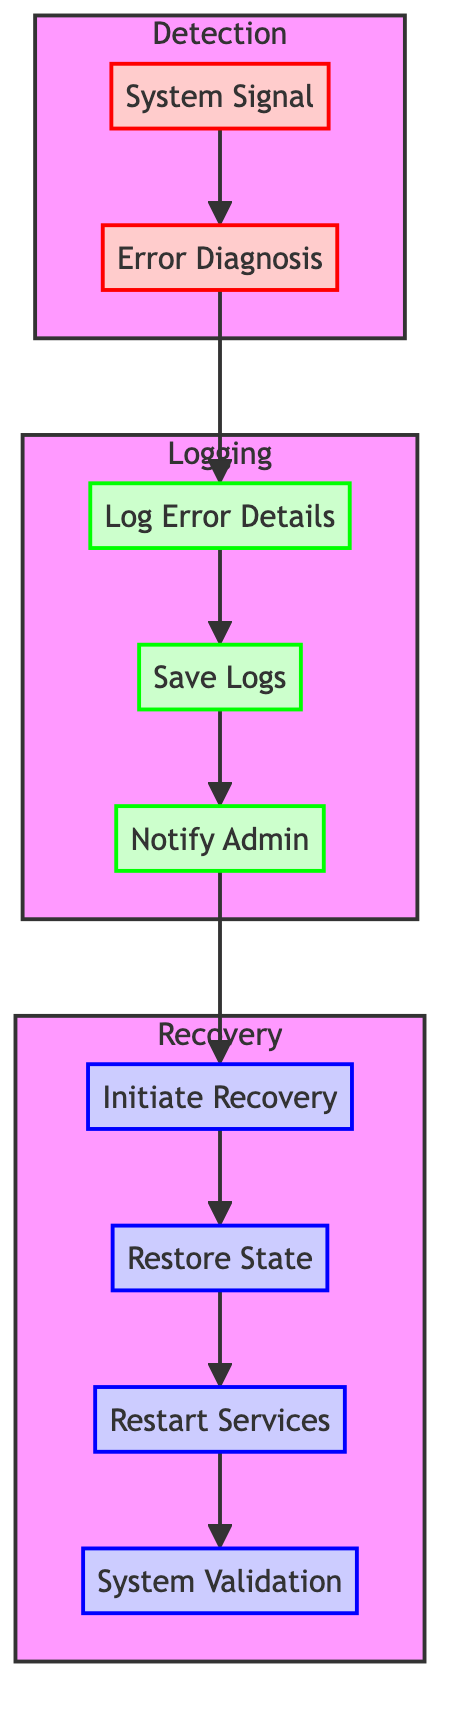What is the first step in the detection phase? The first step in the detection phase is indicated by the node labeled "System Signal," which shows where the detection process begins.
Answer: System Signal How many steps are in the logging phase? The logging phase consists of three steps: "Log Error Details," "Save Logs," and "Notify Admin," as identified by the respective nodes connected in the diagram.
Answer: 3 Which step comes after "Restore State"? Following "Restore State," the next step is "Restart Services," illustrated by the flow indicating the sequence of operations in the recovery phase.
Answer: Restart Services What is logged during the logging phase? The logging phase includes "Log Error Details," which specifically captures the detailed error information for analysis, as showcased in the diagram.
Answer: Detailed error information What is the last step in the recovery phase? The last step depicted in the recovery phase is "System Validation," which comes at the end of the recovery process to ensure system integrity and stability.
Answer: System Validation Describe the flow from error diagnosis to recovery. The flow follows this sequence: "Error Diagnosis" leads to "Log Error Details," which then connects to "Save Logs," and "Notify Admin," followed by the initiation of recovery with "Initiate Recovery," leading to "Restore State," then "Restart Services," and finally "System Validation." This tracking illustrates a clear progression from diagnosing the error to recovering the system's stable state.
Answer: Error Diagnosis to System Validation What color represents the logging phase nodes? The logging phase nodes are colored light green, as indicated by the fill color in the diagram for that specific section.
Answer: Light green Which step directly precedes "Initiate Recovery"? The step that directly precedes "Initiate Recovery" is "Notify Admin," indicating that the notification to administrators occurs before the recovery process starts.
Answer: Notify Admin 